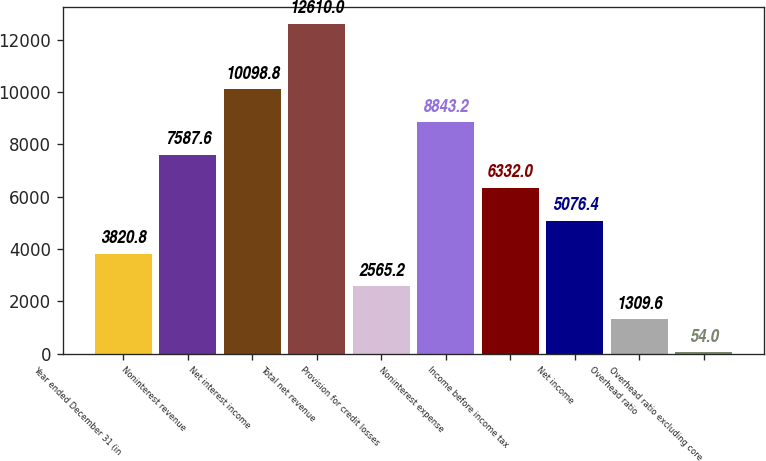Convert chart. <chart><loc_0><loc_0><loc_500><loc_500><bar_chart><fcel>Year ended December 31 (in<fcel>Noninterest revenue<fcel>Net interest income<fcel>Total net revenue<fcel>Provision for credit losses<fcel>Noninterest expense<fcel>Income before income tax<fcel>Net income<fcel>Overhead ratio<fcel>Overhead ratio excluding core<nl><fcel>3820.8<fcel>7587.6<fcel>10098.8<fcel>12610<fcel>2565.2<fcel>8843.2<fcel>6332<fcel>5076.4<fcel>1309.6<fcel>54<nl></chart> 